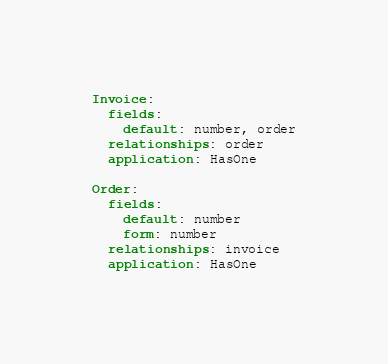Convert code to text. <code><loc_0><loc_0><loc_500><loc_500><_YAML_>Invoice:
  fields:
    default: number, order
  relationships: order
  application: HasOne

Order:
  fields:
    default: number
    form: number
  relationships: invoice
  application: HasOne
</code> 